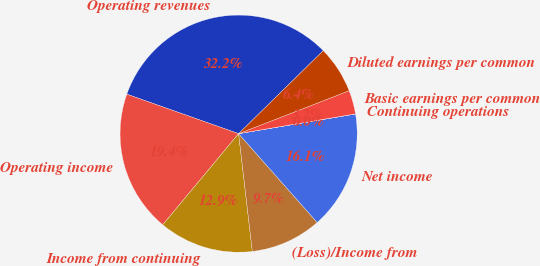<chart> <loc_0><loc_0><loc_500><loc_500><pie_chart><fcel>Operating revenues<fcel>Operating income<fcel>Income from continuing<fcel>(Loss)/Income from<fcel>Net income<fcel>Continuing operations<fcel>Basic earnings per common<fcel>Diluted earnings per common<nl><fcel>32.25%<fcel>19.35%<fcel>12.9%<fcel>9.68%<fcel>16.13%<fcel>0.01%<fcel>3.23%<fcel>6.45%<nl></chart> 